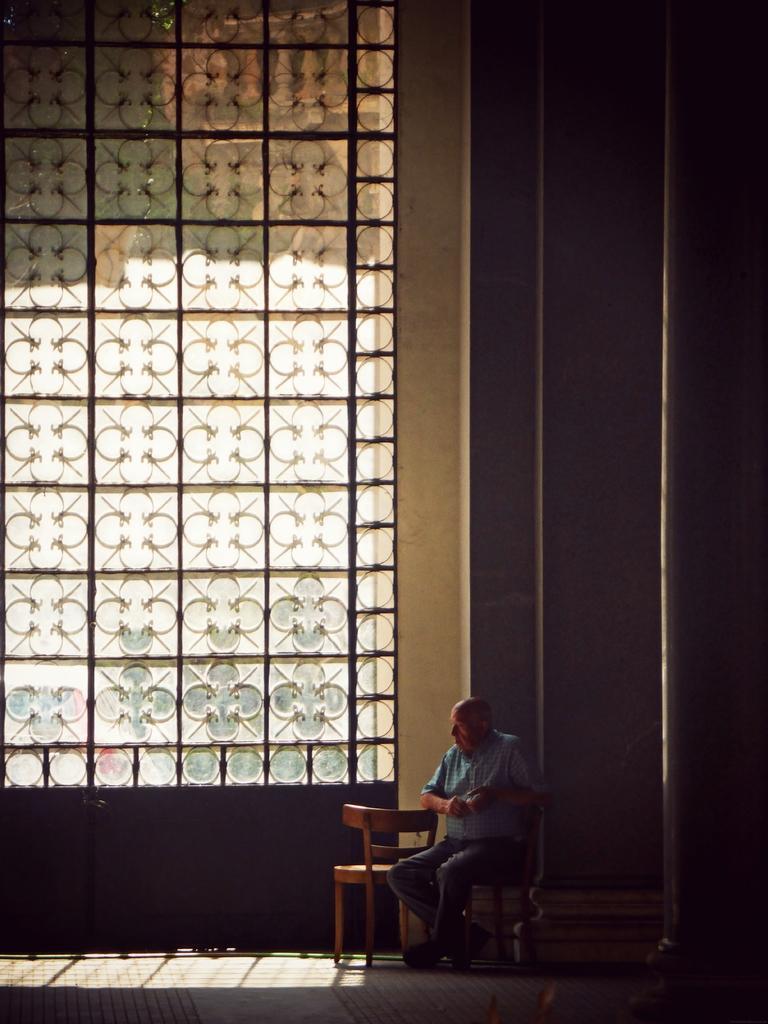Can you describe this image briefly? In this image we can see a person is sitting on the chair and a big glass window. 